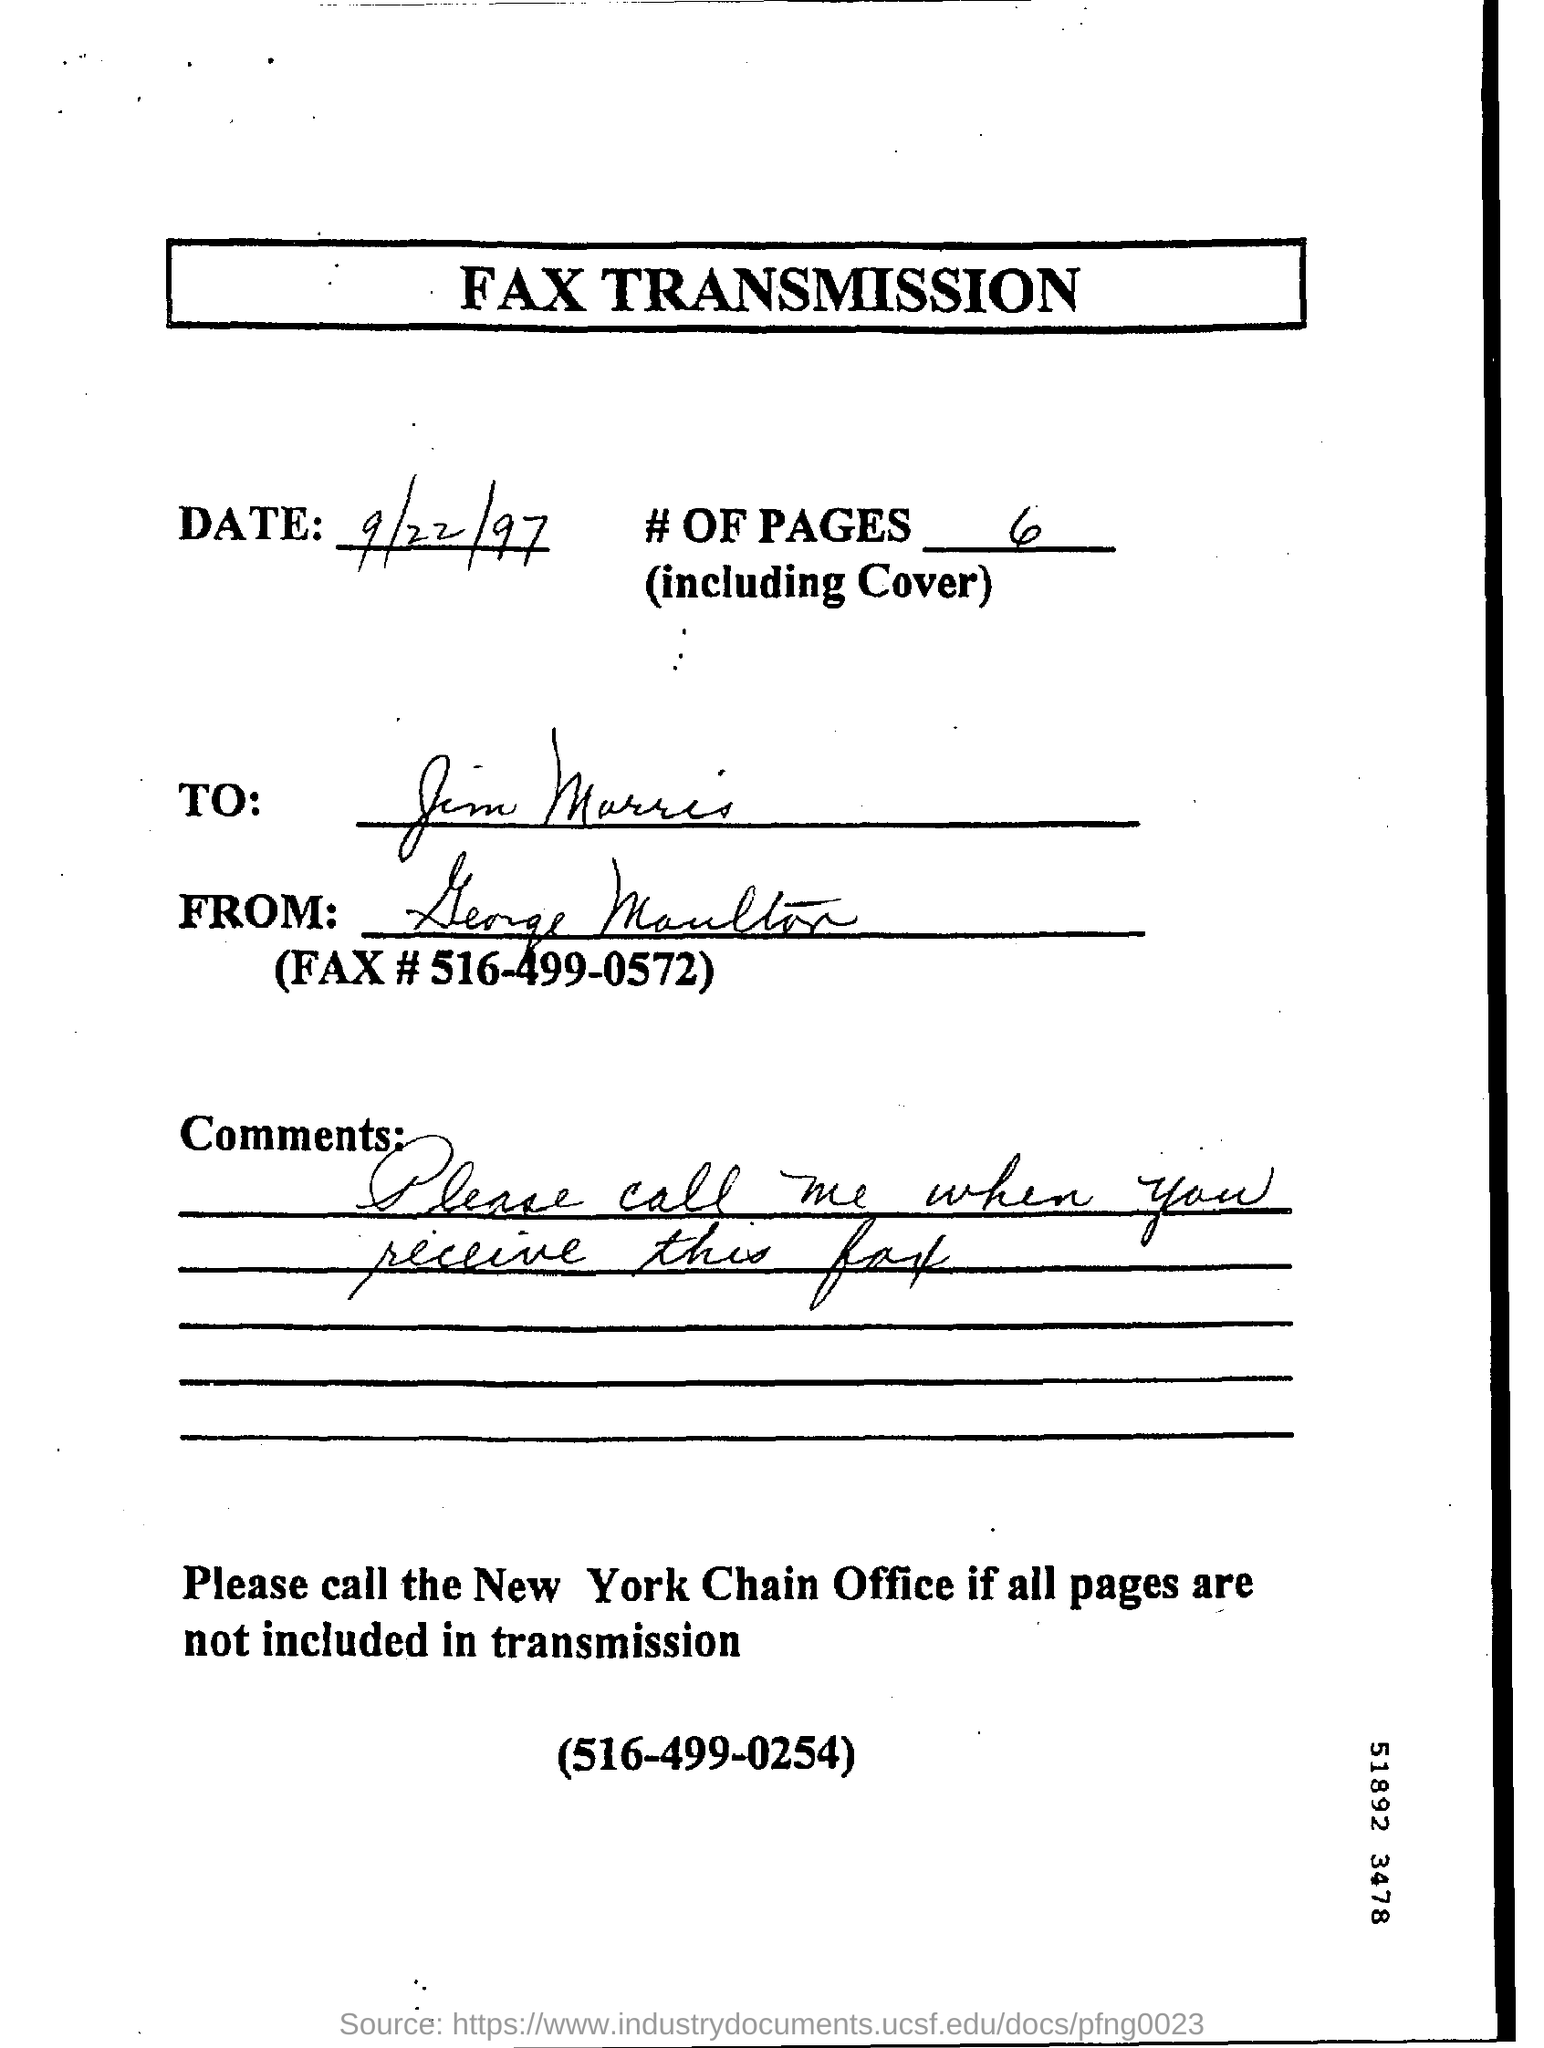How many pages are there in given fax?
Keep it short and to the point. 6. What is the new york chain office number mentioned in fax?
Ensure brevity in your answer.  516-499-0254. 